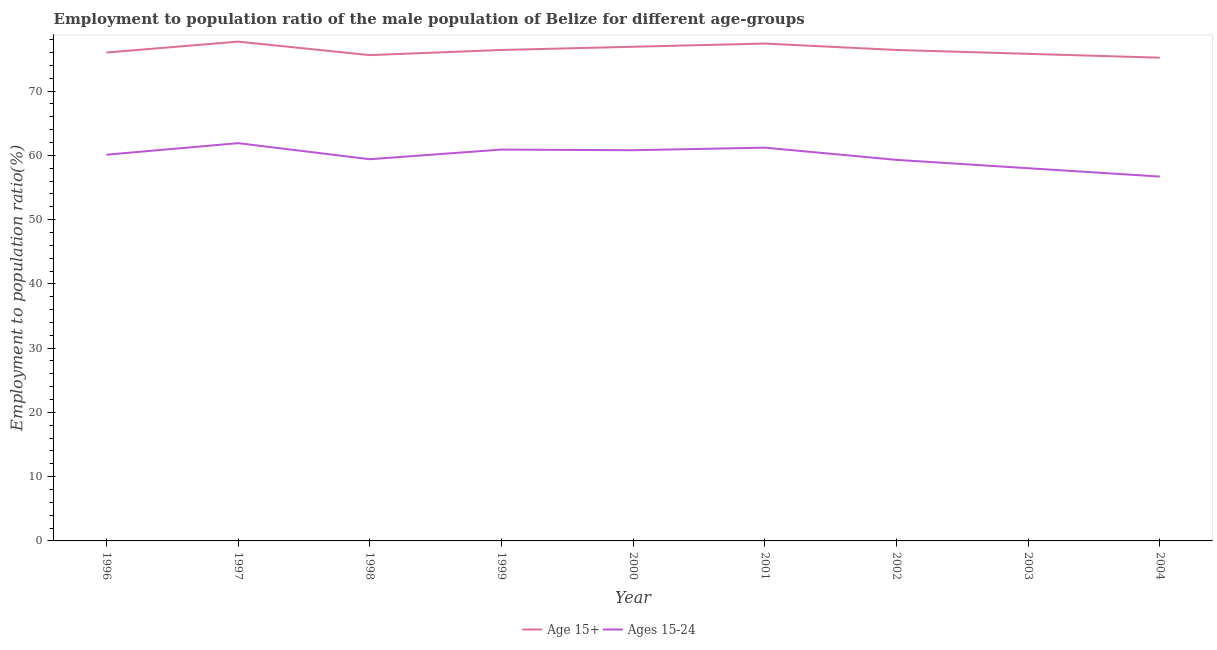Does the line corresponding to employment to population ratio(age 15-24) intersect with the line corresponding to employment to population ratio(age 15+)?
Provide a short and direct response. No. What is the employment to population ratio(age 15-24) in 2001?
Ensure brevity in your answer.  61.2. Across all years, what is the maximum employment to population ratio(age 15-24)?
Keep it short and to the point. 61.9. Across all years, what is the minimum employment to population ratio(age 15-24)?
Your answer should be compact. 56.7. What is the total employment to population ratio(age 15-24) in the graph?
Ensure brevity in your answer.  538.3. What is the difference between the employment to population ratio(age 15-24) in 1997 and that in 2004?
Keep it short and to the point. 5.2. What is the difference between the employment to population ratio(age 15-24) in 2004 and the employment to population ratio(age 15+) in 2001?
Your response must be concise. -20.7. What is the average employment to population ratio(age 15-24) per year?
Offer a terse response. 59.81. In the year 2004, what is the difference between the employment to population ratio(age 15+) and employment to population ratio(age 15-24)?
Provide a short and direct response. 18.5. What is the ratio of the employment to population ratio(age 15+) in 1997 to that in 2003?
Offer a terse response. 1.03. Is the employment to population ratio(age 15-24) in 2001 less than that in 2003?
Offer a very short reply. No. Is the difference between the employment to population ratio(age 15+) in 2000 and 2002 greater than the difference between the employment to population ratio(age 15-24) in 2000 and 2002?
Keep it short and to the point. No. What is the difference between the highest and the second highest employment to population ratio(age 15+)?
Your response must be concise. 0.3. What is the difference between the highest and the lowest employment to population ratio(age 15-24)?
Provide a short and direct response. 5.2. Is the sum of the employment to population ratio(age 15+) in 2000 and 2002 greater than the maximum employment to population ratio(age 15-24) across all years?
Make the answer very short. Yes. Is the employment to population ratio(age 15-24) strictly greater than the employment to population ratio(age 15+) over the years?
Provide a succinct answer. No. How many lines are there?
Keep it short and to the point. 2. How many years are there in the graph?
Ensure brevity in your answer.  9. What is the difference between two consecutive major ticks on the Y-axis?
Offer a very short reply. 10. Are the values on the major ticks of Y-axis written in scientific E-notation?
Give a very brief answer. No. Does the graph contain any zero values?
Offer a terse response. No. Does the graph contain grids?
Offer a very short reply. No. How many legend labels are there?
Ensure brevity in your answer.  2. What is the title of the graph?
Your answer should be very brief. Employment to population ratio of the male population of Belize for different age-groups. Does "DAC donors" appear as one of the legend labels in the graph?
Offer a very short reply. No. What is the label or title of the X-axis?
Offer a terse response. Year. What is the label or title of the Y-axis?
Your response must be concise. Employment to population ratio(%). What is the Employment to population ratio(%) of Age 15+ in 1996?
Your response must be concise. 76. What is the Employment to population ratio(%) of Ages 15-24 in 1996?
Your answer should be compact. 60.1. What is the Employment to population ratio(%) of Age 15+ in 1997?
Your response must be concise. 77.7. What is the Employment to population ratio(%) in Ages 15-24 in 1997?
Your answer should be very brief. 61.9. What is the Employment to population ratio(%) of Age 15+ in 1998?
Provide a succinct answer. 75.6. What is the Employment to population ratio(%) of Ages 15-24 in 1998?
Keep it short and to the point. 59.4. What is the Employment to population ratio(%) of Age 15+ in 1999?
Your answer should be compact. 76.4. What is the Employment to population ratio(%) in Ages 15-24 in 1999?
Provide a succinct answer. 60.9. What is the Employment to population ratio(%) in Age 15+ in 2000?
Give a very brief answer. 76.9. What is the Employment to population ratio(%) in Ages 15-24 in 2000?
Provide a short and direct response. 60.8. What is the Employment to population ratio(%) of Age 15+ in 2001?
Your answer should be very brief. 77.4. What is the Employment to population ratio(%) of Ages 15-24 in 2001?
Your answer should be very brief. 61.2. What is the Employment to population ratio(%) of Age 15+ in 2002?
Your answer should be very brief. 76.4. What is the Employment to population ratio(%) of Ages 15-24 in 2002?
Make the answer very short. 59.3. What is the Employment to population ratio(%) of Age 15+ in 2003?
Your answer should be very brief. 75.8. What is the Employment to population ratio(%) of Ages 15-24 in 2003?
Ensure brevity in your answer.  58. What is the Employment to population ratio(%) of Age 15+ in 2004?
Make the answer very short. 75.2. What is the Employment to population ratio(%) of Ages 15-24 in 2004?
Offer a terse response. 56.7. Across all years, what is the maximum Employment to population ratio(%) in Age 15+?
Your response must be concise. 77.7. Across all years, what is the maximum Employment to population ratio(%) of Ages 15-24?
Keep it short and to the point. 61.9. Across all years, what is the minimum Employment to population ratio(%) of Age 15+?
Give a very brief answer. 75.2. Across all years, what is the minimum Employment to population ratio(%) of Ages 15-24?
Your answer should be compact. 56.7. What is the total Employment to population ratio(%) of Age 15+ in the graph?
Your response must be concise. 687.4. What is the total Employment to population ratio(%) of Ages 15-24 in the graph?
Your response must be concise. 538.3. What is the difference between the Employment to population ratio(%) in Age 15+ in 1996 and that in 1997?
Offer a very short reply. -1.7. What is the difference between the Employment to population ratio(%) in Ages 15-24 in 1996 and that in 1997?
Provide a short and direct response. -1.8. What is the difference between the Employment to population ratio(%) of Age 15+ in 1996 and that in 1998?
Make the answer very short. 0.4. What is the difference between the Employment to population ratio(%) in Ages 15-24 in 1996 and that in 1998?
Provide a succinct answer. 0.7. What is the difference between the Employment to population ratio(%) in Age 15+ in 1996 and that in 1999?
Ensure brevity in your answer.  -0.4. What is the difference between the Employment to population ratio(%) in Ages 15-24 in 1996 and that in 1999?
Offer a very short reply. -0.8. What is the difference between the Employment to population ratio(%) in Ages 15-24 in 1996 and that in 2000?
Make the answer very short. -0.7. What is the difference between the Employment to population ratio(%) of Ages 15-24 in 1996 and that in 2001?
Offer a terse response. -1.1. What is the difference between the Employment to population ratio(%) in Ages 15-24 in 1996 and that in 2002?
Provide a succinct answer. 0.8. What is the difference between the Employment to population ratio(%) in Age 15+ in 1996 and that in 2003?
Your response must be concise. 0.2. What is the difference between the Employment to population ratio(%) in Ages 15-24 in 1996 and that in 2004?
Provide a succinct answer. 3.4. What is the difference between the Employment to population ratio(%) of Ages 15-24 in 1997 and that in 1998?
Give a very brief answer. 2.5. What is the difference between the Employment to population ratio(%) in Ages 15-24 in 1997 and that in 2000?
Your answer should be very brief. 1.1. What is the difference between the Employment to population ratio(%) of Ages 15-24 in 1997 and that in 2001?
Make the answer very short. 0.7. What is the difference between the Employment to population ratio(%) of Age 15+ in 1997 and that in 2002?
Ensure brevity in your answer.  1.3. What is the difference between the Employment to population ratio(%) of Ages 15-24 in 1997 and that in 2002?
Provide a short and direct response. 2.6. What is the difference between the Employment to population ratio(%) in Age 15+ in 1997 and that in 2003?
Your response must be concise. 1.9. What is the difference between the Employment to population ratio(%) of Ages 15-24 in 1997 and that in 2003?
Keep it short and to the point. 3.9. What is the difference between the Employment to population ratio(%) of Age 15+ in 1997 and that in 2004?
Your answer should be compact. 2.5. What is the difference between the Employment to population ratio(%) of Ages 15-24 in 1998 and that in 1999?
Give a very brief answer. -1.5. What is the difference between the Employment to population ratio(%) of Age 15+ in 1998 and that in 2000?
Provide a succinct answer. -1.3. What is the difference between the Employment to population ratio(%) of Ages 15-24 in 1998 and that in 2002?
Offer a terse response. 0.1. What is the difference between the Employment to population ratio(%) of Age 15+ in 1998 and that in 2003?
Provide a succinct answer. -0.2. What is the difference between the Employment to population ratio(%) of Ages 15-24 in 1998 and that in 2003?
Provide a short and direct response. 1.4. What is the difference between the Employment to population ratio(%) in Age 15+ in 1998 and that in 2004?
Offer a terse response. 0.4. What is the difference between the Employment to population ratio(%) in Ages 15-24 in 1998 and that in 2004?
Offer a very short reply. 2.7. What is the difference between the Employment to population ratio(%) in Ages 15-24 in 1999 and that in 2000?
Provide a short and direct response. 0.1. What is the difference between the Employment to population ratio(%) of Age 15+ in 1999 and that in 2002?
Your answer should be compact. 0. What is the difference between the Employment to population ratio(%) of Ages 15-24 in 1999 and that in 2002?
Provide a short and direct response. 1.6. What is the difference between the Employment to population ratio(%) in Age 15+ in 1999 and that in 2003?
Your response must be concise. 0.6. What is the difference between the Employment to population ratio(%) of Age 15+ in 1999 and that in 2004?
Ensure brevity in your answer.  1.2. What is the difference between the Employment to population ratio(%) of Age 15+ in 2000 and that in 2002?
Ensure brevity in your answer.  0.5. What is the difference between the Employment to population ratio(%) in Age 15+ in 2000 and that in 2003?
Ensure brevity in your answer.  1.1. What is the difference between the Employment to population ratio(%) in Ages 15-24 in 2000 and that in 2003?
Provide a short and direct response. 2.8. What is the difference between the Employment to population ratio(%) of Ages 15-24 in 2000 and that in 2004?
Your answer should be very brief. 4.1. What is the difference between the Employment to population ratio(%) in Age 15+ in 2001 and that in 2003?
Your answer should be very brief. 1.6. What is the difference between the Employment to population ratio(%) in Ages 15-24 in 2001 and that in 2003?
Give a very brief answer. 3.2. What is the difference between the Employment to population ratio(%) in Age 15+ in 2001 and that in 2004?
Your answer should be very brief. 2.2. What is the difference between the Employment to population ratio(%) in Ages 15-24 in 2002 and that in 2003?
Ensure brevity in your answer.  1.3. What is the difference between the Employment to population ratio(%) in Age 15+ in 2003 and that in 2004?
Make the answer very short. 0.6. What is the difference between the Employment to population ratio(%) in Age 15+ in 1996 and the Employment to population ratio(%) in Ages 15-24 in 1998?
Your answer should be very brief. 16.6. What is the difference between the Employment to population ratio(%) of Age 15+ in 1996 and the Employment to population ratio(%) of Ages 15-24 in 1999?
Your answer should be very brief. 15.1. What is the difference between the Employment to population ratio(%) in Age 15+ in 1996 and the Employment to population ratio(%) in Ages 15-24 in 2001?
Keep it short and to the point. 14.8. What is the difference between the Employment to population ratio(%) of Age 15+ in 1996 and the Employment to population ratio(%) of Ages 15-24 in 2002?
Your answer should be compact. 16.7. What is the difference between the Employment to population ratio(%) of Age 15+ in 1996 and the Employment to population ratio(%) of Ages 15-24 in 2004?
Offer a terse response. 19.3. What is the difference between the Employment to population ratio(%) in Age 15+ in 1997 and the Employment to population ratio(%) in Ages 15-24 in 2000?
Your response must be concise. 16.9. What is the difference between the Employment to population ratio(%) in Age 15+ in 1997 and the Employment to population ratio(%) in Ages 15-24 in 2002?
Your answer should be compact. 18.4. What is the difference between the Employment to population ratio(%) in Age 15+ in 1997 and the Employment to population ratio(%) in Ages 15-24 in 2004?
Keep it short and to the point. 21. What is the difference between the Employment to population ratio(%) in Age 15+ in 1998 and the Employment to population ratio(%) in Ages 15-24 in 1999?
Make the answer very short. 14.7. What is the difference between the Employment to population ratio(%) in Age 15+ in 1998 and the Employment to population ratio(%) in Ages 15-24 in 2003?
Your response must be concise. 17.6. What is the difference between the Employment to population ratio(%) of Age 15+ in 1998 and the Employment to population ratio(%) of Ages 15-24 in 2004?
Offer a terse response. 18.9. What is the difference between the Employment to population ratio(%) of Age 15+ in 1999 and the Employment to population ratio(%) of Ages 15-24 in 2002?
Provide a succinct answer. 17.1. What is the difference between the Employment to population ratio(%) in Age 15+ in 1999 and the Employment to population ratio(%) in Ages 15-24 in 2004?
Offer a very short reply. 19.7. What is the difference between the Employment to population ratio(%) of Age 15+ in 2000 and the Employment to population ratio(%) of Ages 15-24 in 2004?
Your answer should be very brief. 20.2. What is the difference between the Employment to population ratio(%) of Age 15+ in 2001 and the Employment to population ratio(%) of Ages 15-24 in 2003?
Make the answer very short. 19.4. What is the difference between the Employment to population ratio(%) in Age 15+ in 2001 and the Employment to population ratio(%) in Ages 15-24 in 2004?
Offer a very short reply. 20.7. What is the difference between the Employment to population ratio(%) of Age 15+ in 2002 and the Employment to population ratio(%) of Ages 15-24 in 2004?
Make the answer very short. 19.7. What is the average Employment to population ratio(%) of Age 15+ per year?
Provide a short and direct response. 76.38. What is the average Employment to population ratio(%) of Ages 15-24 per year?
Give a very brief answer. 59.81. In the year 1996, what is the difference between the Employment to population ratio(%) in Age 15+ and Employment to population ratio(%) in Ages 15-24?
Provide a succinct answer. 15.9. In the year 1997, what is the difference between the Employment to population ratio(%) of Age 15+ and Employment to population ratio(%) of Ages 15-24?
Ensure brevity in your answer.  15.8. In the year 1998, what is the difference between the Employment to population ratio(%) of Age 15+ and Employment to population ratio(%) of Ages 15-24?
Your answer should be very brief. 16.2. In the year 2000, what is the difference between the Employment to population ratio(%) of Age 15+ and Employment to population ratio(%) of Ages 15-24?
Your answer should be compact. 16.1. In the year 2001, what is the difference between the Employment to population ratio(%) in Age 15+ and Employment to population ratio(%) in Ages 15-24?
Provide a succinct answer. 16.2. In the year 2002, what is the difference between the Employment to population ratio(%) of Age 15+ and Employment to population ratio(%) of Ages 15-24?
Offer a very short reply. 17.1. What is the ratio of the Employment to population ratio(%) of Age 15+ in 1996 to that in 1997?
Your answer should be very brief. 0.98. What is the ratio of the Employment to population ratio(%) in Ages 15-24 in 1996 to that in 1997?
Your answer should be very brief. 0.97. What is the ratio of the Employment to population ratio(%) of Age 15+ in 1996 to that in 1998?
Offer a very short reply. 1.01. What is the ratio of the Employment to population ratio(%) of Ages 15-24 in 1996 to that in 1998?
Provide a short and direct response. 1.01. What is the ratio of the Employment to population ratio(%) in Ages 15-24 in 1996 to that in 1999?
Ensure brevity in your answer.  0.99. What is the ratio of the Employment to population ratio(%) in Age 15+ in 1996 to that in 2000?
Your answer should be very brief. 0.99. What is the ratio of the Employment to population ratio(%) of Age 15+ in 1996 to that in 2001?
Give a very brief answer. 0.98. What is the ratio of the Employment to population ratio(%) in Ages 15-24 in 1996 to that in 2002?
Offer a very short reply. 1.01. What is the ratio of the Employment to population ratio(%) of Ages 15-24 in 1996 to that in 2003?
Keep it short and to the point. 1.04. What is the ratio of the Employment to population ratio(%) of Age 15+ in 1996 to that in 2004?
Provide a short and direct response. 1.01. What is the ratio of the Employment to population ratio(%) of Ages 15-24 in 1996 to that in 2004?
Ensure brevity in your answer.  1.06. What is the ratio of the Employment to population ratio(%) of Age 15+ in 1997 to that in 1998?
Your response must be concise. 1.03. What is the ratio of the Employment to population ratio(%) in Ages 15-24 in 1997 to that in 1998?
Provide a succinct answer. 1.04. What is the ratio of the Employment to population ratio(%) in Age 15+ in 1997 to that in 1999?
Offer a very short reply. 1.02. What is the ratio of the Employment to population ratio(%) in Ages 15-24 in 1997 to that in 1999?
Offer a terse response. 1.02. What is the ratio of the Employment to population ratio(%) of Age 15+ in 1997 to that in 2000?
Your response must be concise. 1.01. What is the ratio of the Employment to population ratio(%) of Ages 15-24 in 1997 to that in 2000?
Give a very brief answer. 1.02. What is the ratio of the Employment to population ratio(%) of Age 15+ in 1997 to that in 2001?
Your answer should be compact. 1. What is the ratio of the Employment to population ratio(%) of Ages 15-24 in 1997 to that in 2001?
Your answer should be very brief. 1.01. What is the ratio of the Employment to population ratio(%) in Age 15+ in 1997 to that in 2002?
Provide a succinct answer. 1.02. What is the ratio of the Employment to population ratio(%) of Ages 15-24 in 1997 to that in 2002?
Provide a short and direct response. 1.04. What is the ratio of the Employment to population ratio(%) of Age 15+ in 1997 to that in 2003?
Offer a very short reply. 1.03. What is the ratio of the Employment to population ratio(%) in Ages 15-24 in 1997 to that in 2003?
Ensure brevity in your answer.  1.07. What is the ratio of the Employment to population ratio(%) of Age 15+ in 1997 to that in 2004?
Provide a short and direct response. 1.03. What is the ratio of the Employment to population ratio(%) of Ages 15-24 in 1997 to that in 2004?
Offer a very short reply. 1.09. What is the ratio of the Employment to population ratio(%) of Ages 15-24 in 1998 to that in 1999?
Ensure brevity in your answer.  0.98. What is the ratio of the Employment to population ratio(%) of Age 15+ in 1998 to that in 2000?
Provide a succinct answer. 0.98. What is the ratio of the Employment to population ratio(%) in Ages 15-24 in 1998 to that in 2000?
Your answer should be very brief. 0.98. What is the ratio of the Employment to population ratio(%) in Age 15+ in 1998 to that in 2001?
Offer a very short reply. 0.98. What is the ratio of the Employment to population ratio(%) in Ages 15-24 in 1998 to that in 2001?
Provide a short and direct response. 0.97. What is the ratio of the Employment to population ratio(%) of Ages 15-24 in 1998 to that in 2002?
Keep it short and to the point. 1. What is the ratio of the Employment to population ratio(%) of Ages 15-24 in 1998 to that in 2003?
Provide a succinct answer. 1.02. What is the ratio of the Employment to population ratio(%) of Ages 15-24 in 1998 to that in 2004?
Give a very brief answer. 1.05. What is the ratio of the Employment to population ratio(%) of Age 15+ in 1999 to that in 2000?
Offer a terse response. 0.99. What is the ratio of the Employment to population ratio(%) in Ages 15-24 in 1999 to that in 2000?
Provide a short and direct response. 1. What is the ratio of the Employment to population ratio(%) of Age 15+ in 1999 to that in 2001?
Give a very brief answer. 0.99. What is the ratio of the Employment to population ratio(%) of Ages 15-24 in 1999 to that in 2001?
Provide a succinct answer. 1. What is the ratio of the Employment to population ratio(%) of Ages 15-24 in 1999 to that in 2002?
Your answer should be very brief. 1.03. What is the ratio of the Employment to population ratio(%) in Age 15+ in 1999 to that in 2003?
Your answer should be compact. 1.01. What is the ratio of the Employment to population ratio(%) in Ages 15-24 in 1999 to that in 2003?
Provide a succinct answer. 1.05. What is the ratio of the Employment to population ratio(%) in Age 15+ in 1999 to that in 2004?
Keep it short and to the point. 1.02. What is the ratio of the Employment to population ratio(%) in Ages 15-24 in 1999 to that in 2004?
Ensure brevity in your answer.  1.07. What is the ratio of the Employment to population ratio(%) in Age 15+ in 2000 to that in 2001?
Your response must be concise. 0.99. What is the ratio of the Employment to population ratio(%) in Ages 15-24 in 2000 to that in 2001?
Make the answer very short. 0.99. What is the ratio of the Employment to population ratio(%) in Ages 15-24 in 2000 to that in 2002?
Provide a short and direct response. 1.03. What is the ratio of the Employment to population ratio(%) in Age 15+ in 2000 to that in 2003?
Ensure brevity in your answer.  1.01. What is the ratio of the Employment to population ratio(%) in Ages 15-24 in 2000 to that in 2003?
Your response must be concise. 1.05. What is the ratio of the Employment to population ratio(%) of Age 15+ in 2000 to that in 2004?
Make the answer very short. 1.02. What is the ratio of the Employment to population ratio(%) of Ages 15-24 in 2000 to that in 2004?
Give a very brief answer. 1.07. What is the ratio of the Employment to population ratio(%) in Age 15+ in 2001 to that in 2002?
Your answer should be very brief. 1.01. What is the ratio of the Employment to population ratio(%) of Ages 15-24 in 2001 to that in 2002?
Your answer should be very brief. 1.03. What is the ratio of the Employment to population ratio(%) in Age 15+ in 2001 to that in 2003?
Your response must be concise. 1.02. What is the ratio of the Employment to population ratio(%) of Ages 15-24 in 2001 to that in 2003?
Your answer should be compact. 1.06. What is the ratio of the Employment to population ratio(%) in Age 15+ in 2001 to that in 2004?
Give a very brief answer. 1.03. What is the ratio of the Employment to population ratio(%) of Ages 15-24 in 2001 to that in 2004?
Provide a succinct answer. 1.08. What is the ratio of the Employment to population ratio(%) in Age 15+ in 2002 to that in 2003?
Give a very brief answer. 1.01. What is the ratio of the Employment to population ratio(%) of Ages 15-24 in 2002 to that in 2003?
Your answer should be very brief. 1.02. What is the ratio of the Employment to population ratio(%) of Age 15+ in 2002 to that in 2004?
Your answer should be compact. 1.02. What is the ratio of the Employment to population ratio(%) in Ages 15-24 in 2002 to that in 2004?
Ensure brevity in your answer.  1.05. What is the ratio of the Employment to population ratio(%) in Age 15+ in 2003 to that in 2004?
Your answer should be compact. 1.01. What is the ratio of the Employment to population ratio(%) in Ages 15-24 in 2003 to that in 2004?
Give a very brief answer. 1.02. What is the difference between the highest and the lowest Employment to population ratio(%) in Ages 15-24?
Ensure brevity in your answer.  5.2. 